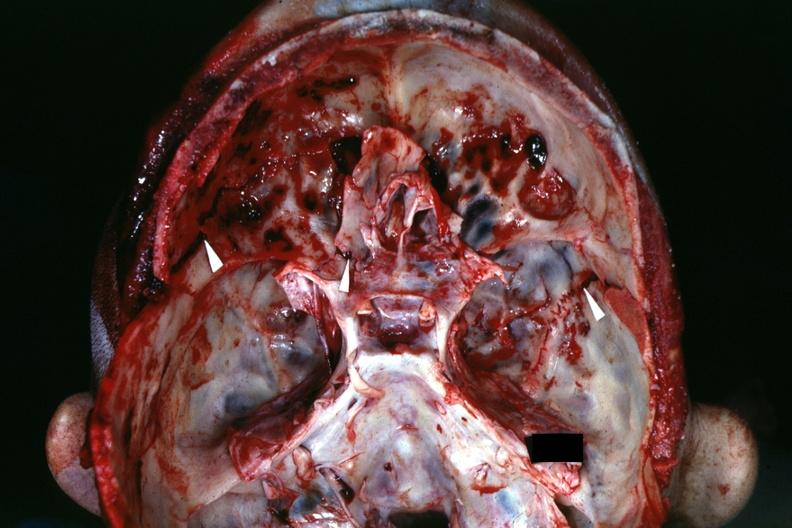s basilar skull fracture present?
Answer the question using a single word or phrase. Yes 